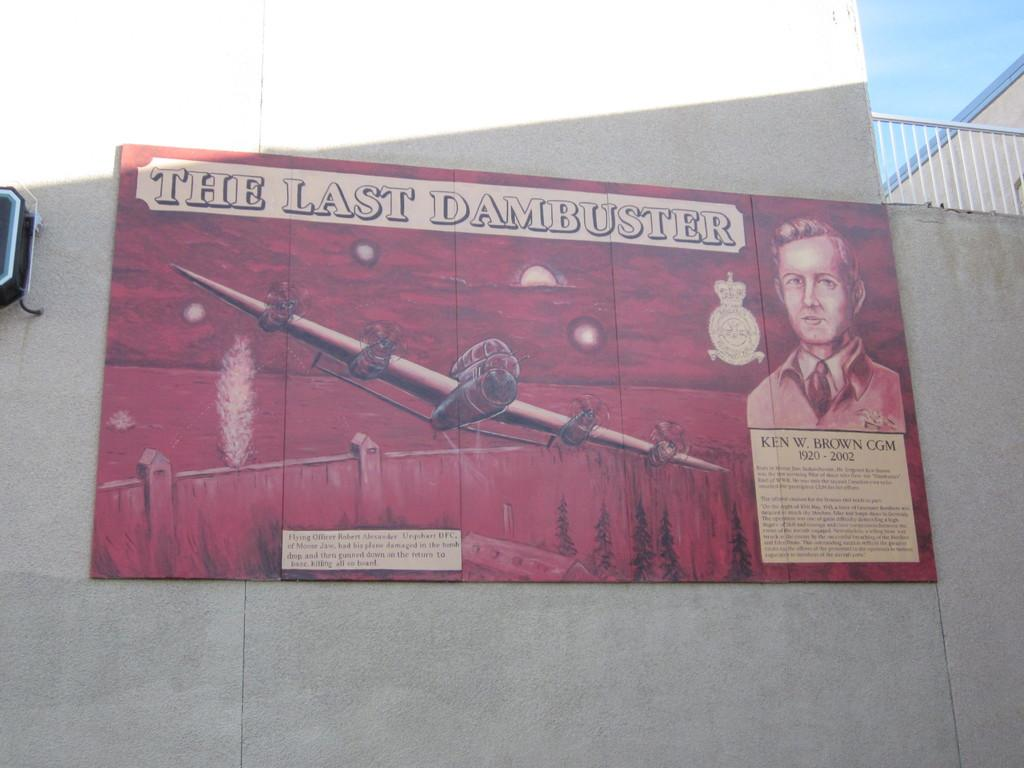<image>
Give a short and clear explanation of the subsequent image. A red poster featuring an airplane that is advertising a show called The Last Dambuster. 